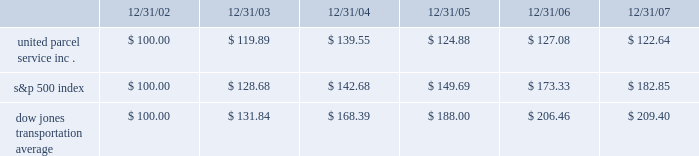Shareowner return performance graph the following performance graph and related information shall not be deemed 201csoliciting material 201d or to be 201cfiled 201d with the securities and exchange commission , nor shall such information be incorporated by reference into any future filing under the securities act of 1933 or securities exchange act of 1934 , each as amended , except to the extent that the company specifically incorporates such information by reference into such filing .
The following graph shows a five-year comparison of cumulative total shareowners 2019 returns for our class b common stock , the s&p 500 index , and the dow jones transportation average .
The comparison of the total cumulative return on investment , which is the change in the quarterly stock price plus reinvested dividends for each of the quarterly periods , assumes that $ 100 was invested on december 31 , 2002 in the s&p 500 index , the dow jones transportation average , and the class b common stock of united parcel service , inc .
Comparison of five year cumulative total return $ 40.00 $ 60.00 $ 80.00 $ 100.00 $ 120.00 $ 140.00 $ 160.00 $ 180.00 $ 200.00 $ 220.00 2002 20072006200520042003 s&p 500 ups dj transport .
Securities authorized for issuance under equity compensation plans the following table provides information as of december 31 , 2007 regarding compensation plans under which our class a common stock is authorized for issuance .
These plans do not authorize the issuance of our class b common stock. .
What is the rate of return of an investment in ups from 2002 to 2003? 
Computations: ((119.89 - 100) / 100)
Answer: 0.1989. 